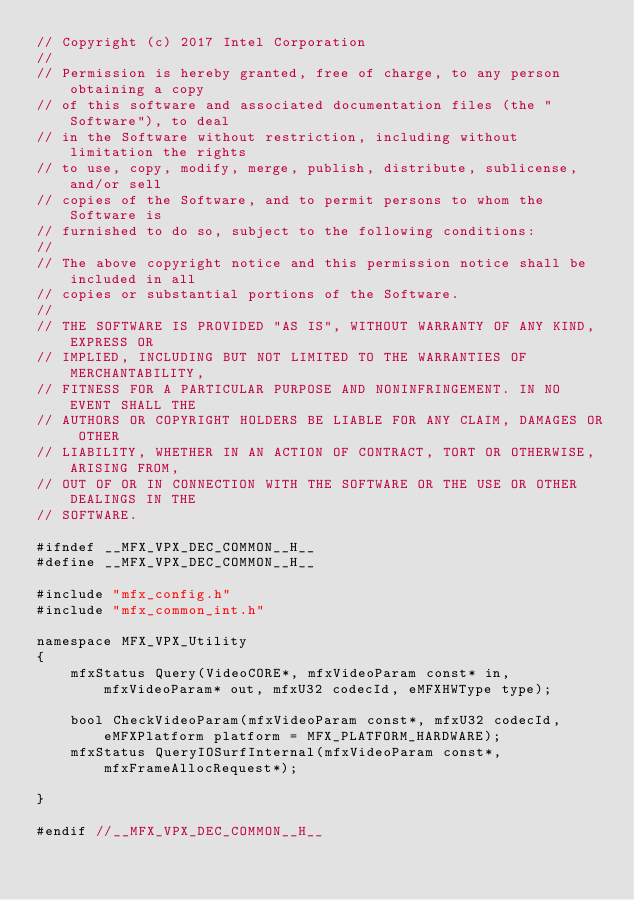Convert code to text. <code><loc_0><loc_0><loc_500><loc_500><_C_>// Copyright (c) 2017 Intel Corporation
// 
// Permission is hereby granted, free of charge, to any person obtaining a copy
// of this software and associated documentation files (the "Software"), to deal
// in the Software without restriction, including without limitation the rights
// to use, copy, modify, merge, publish, distribute, sublicense, and/or sell
// copies of the Software, and to permit persons to whom the Software is
// furnished to do so, subject to the following conditions:
// 
// The above copyright notice and this permission notice shall be included in all
// copies or substantial portions of the Software.
// 
// THE SOFTWARE IS PROVIDED "AS IS", WITHOUT WARRANTY OF ANY KIND, EXPRESS OR
// IMPLIED, INCLUDING BUT NOT LIMITED TO THE WARRANTIES OF MERCHANTABILITY,
// FITNESS FOR A PARTICULAR PURPOSE AND NONINFRINGEMENT. IN NO EVENT SHALL THE
// AUTHORS OR COPYRIGHT HOLDERS BE LIABLE FOR ANY CLAIM, DAMAGES OR OTHER
// LIABILITY, WHETHER IN AN ACTION OF CONTRACT, TORT OR OTHERWISE, ARISING FROM,
// OUT OF OR IN CONNECTION WITH THE SOFTWARE OR THE USE OR OTHER DEALINGS IN THE
// SOFTWARE.

#ifndef __MFX_VPX_DEC_COMMON__H__
#define __MFX_VPX_DEC_COMMON__H__

#include "mfx_config.h"
#include "mfx_common_int.h"

namespace MFX_VPX_Utility
{
    mfxStatus Query(VideoCORE*, mfxVideoParam const* in, mfxVideoParam* out, mfxU32 codecId, eMFXHWType type);

    bool CheckVideoParam(mfxVideoParam const*, mfxU32 codecId, eMFXPlatform platform = MFX_PLATFORM_HARDWARE);
    mfxStatus QueryIOSurfInternal(mfxVideoParam const*, mfxFrameAllocRequest*);

}

#endif //__MFX_VPX_DEC_COMMON__H__
</code> 